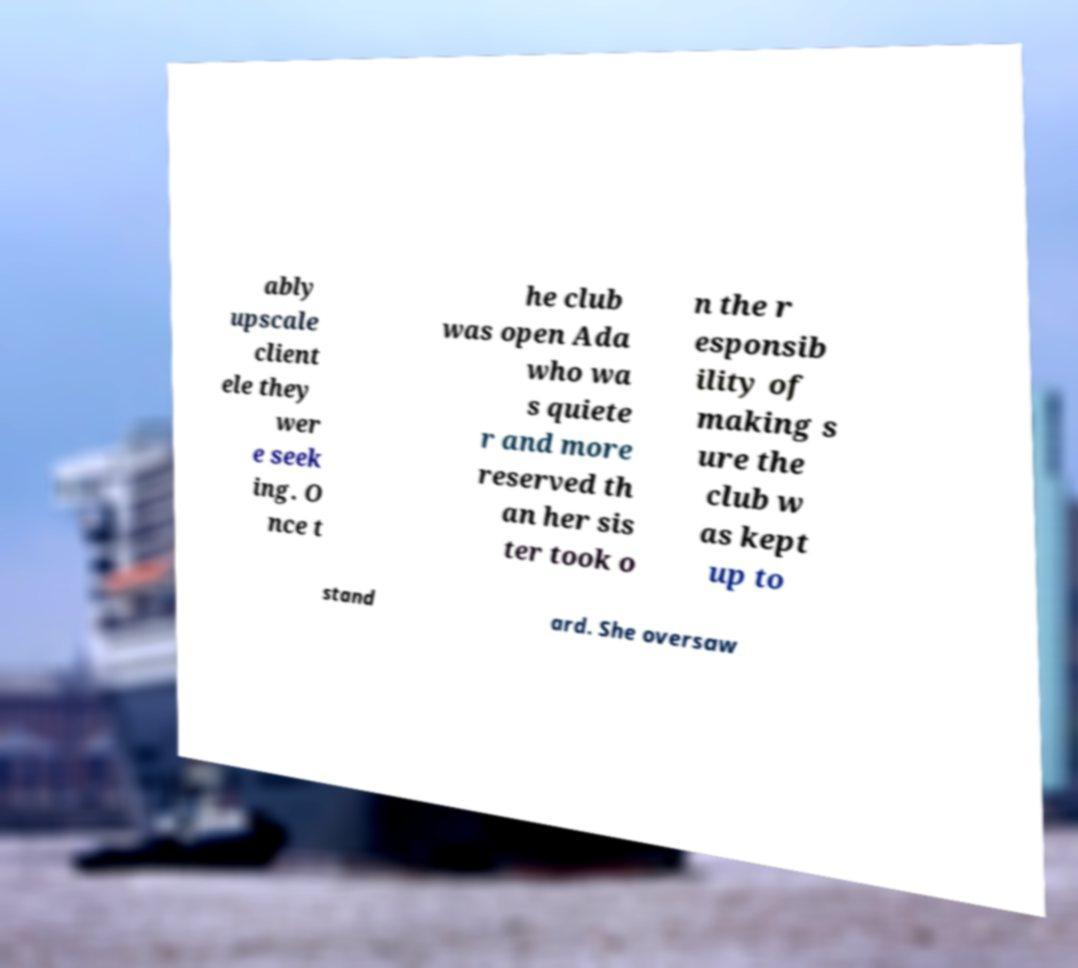Could you assist in decoding the text presented in this image and type it out clearly? ably upscale client ele they wer e seek ing. O nce t he club was open Ada who wa s quiete r and more reserved th an her sis ter took o n the r esponsib ility of making s ure the club w as kept up to stand ard. She oversaw 